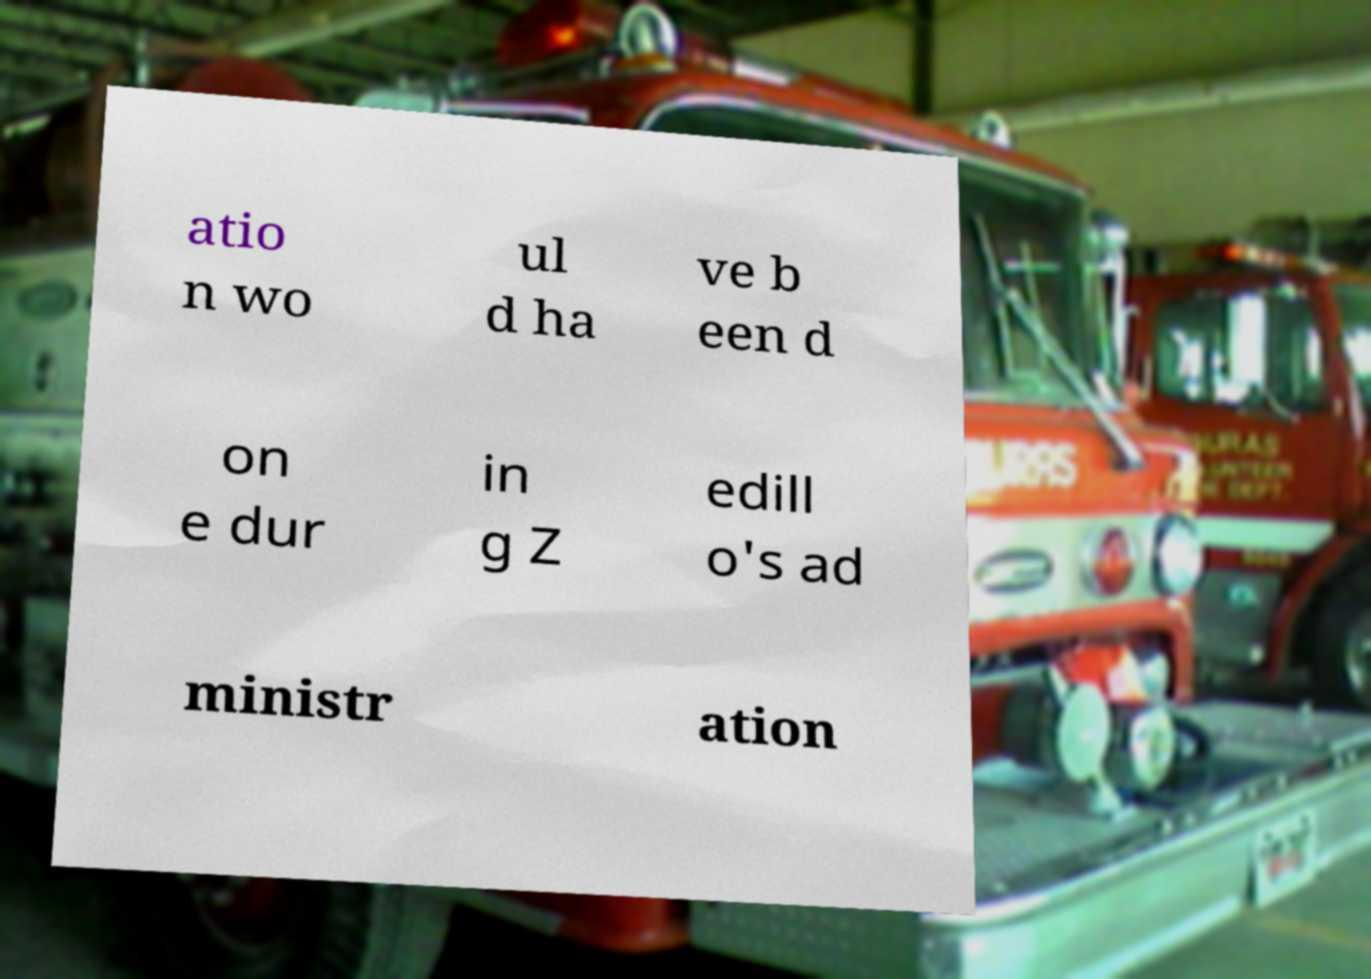For documentation purposes, I need the text within this image transcribed. Could you provide that? atio n wo ul d ha ve b een d on e dur in g Z edill o's ad ministr ation 